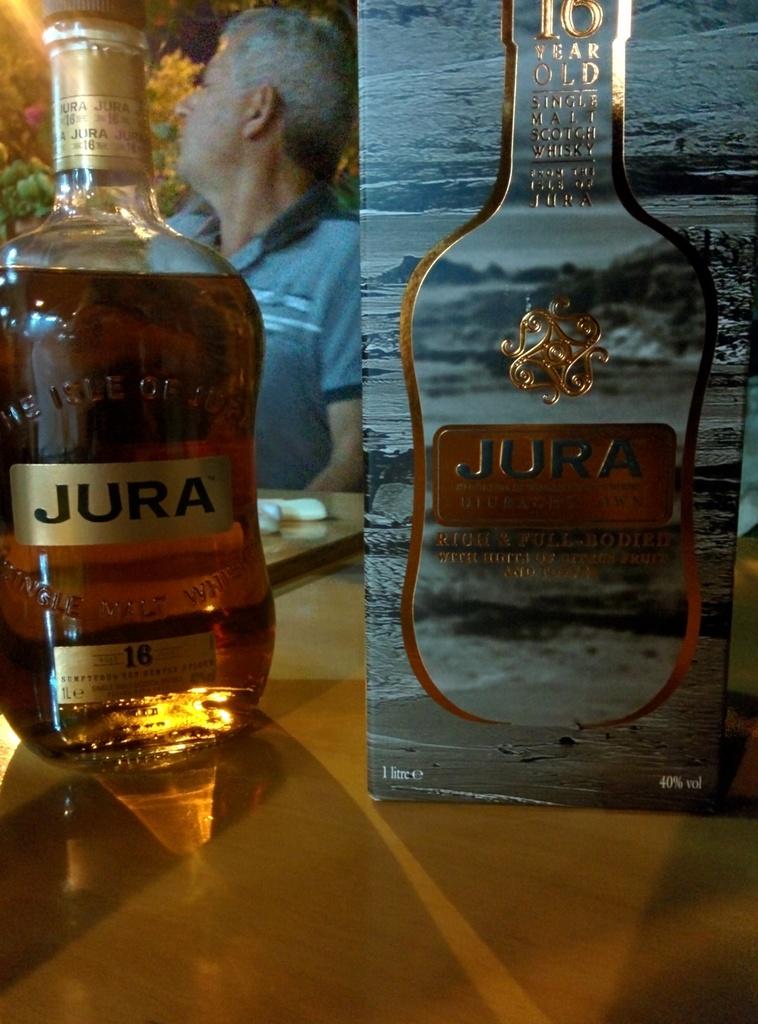What percent alcohol is this drink?
Your answer should be very brief. 40%. Who makes that liquor?
Your answer should be compact. Jura. 